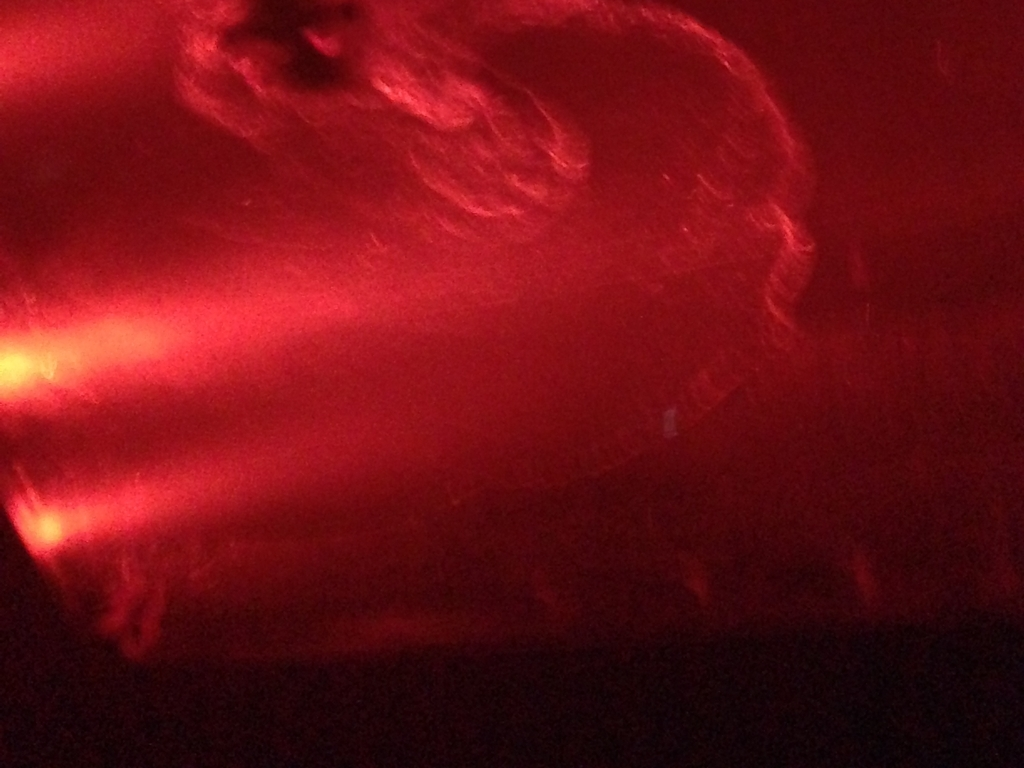What could be the cause of the overwhelming red hue in this image? The red hue might be due to the lighting conditions at the time of the photograph, such as red lights or a strong reflection of red objects. Alternatively, it might also be a result of color balance settings in the camera, where the red tones were overly emphasized during the capture process. 